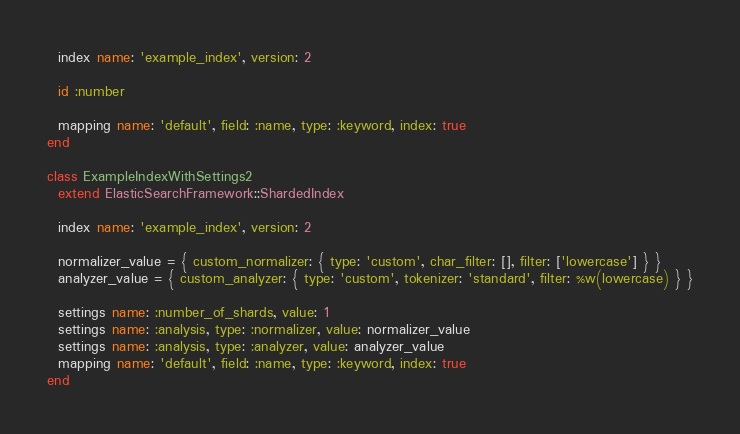Convert code to text. <code><loc_0><loc_0><loc_500><loc_500><_Ruby_>  index name: 'example_index', version: 2

  id :number

  mapping name: 'default', field: :name, type: :keyword, index: true
end

class ExampleIndexWithSettings2
  extend ElasticSearchFramework::ShardedIndex

  index name: 'example_index', version: 2

  normalizer_value = { custom_normalizer: { type: 'custom', char_filter: [], filter: ['lowercase'] } }
  analyzer_value = { custom_analyzer: { type: 'custom', tokenizer: 'standard', filter: %w(lowercase) } }

  settings name: :number_of_shards, value: 1
  settings name: :analysis, type: :normalizer, value: normalizer_value
  settings name: :analysis, type: :analyzer, value: analyzer_value
  mapping name: 'default', field: :name, type: :keyword, index: true
end
</code> 